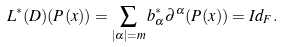<formula> <loc_0><loc_0><loc_500><loc_500>L ^ { * } ( D ) ( P ( x ) ) = \sum _ { | \alpha | = m } b ^ { \ast } _ { \alpha } \partial ^ { \alpha } ( P ( x ) ) = I d _ { F } .</formula> 